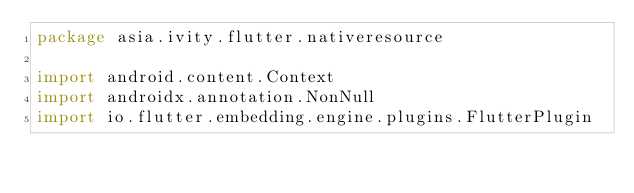<code> <loc_0><loc_0><loc_500><loc_500><_Kotlin_>package asia.ivity.flutter.nativeresource

import android.content.Context
import androidx.annotation.NonNull
import io.flutter.embedding.engine.plugins.FlutterPlugin</code> 